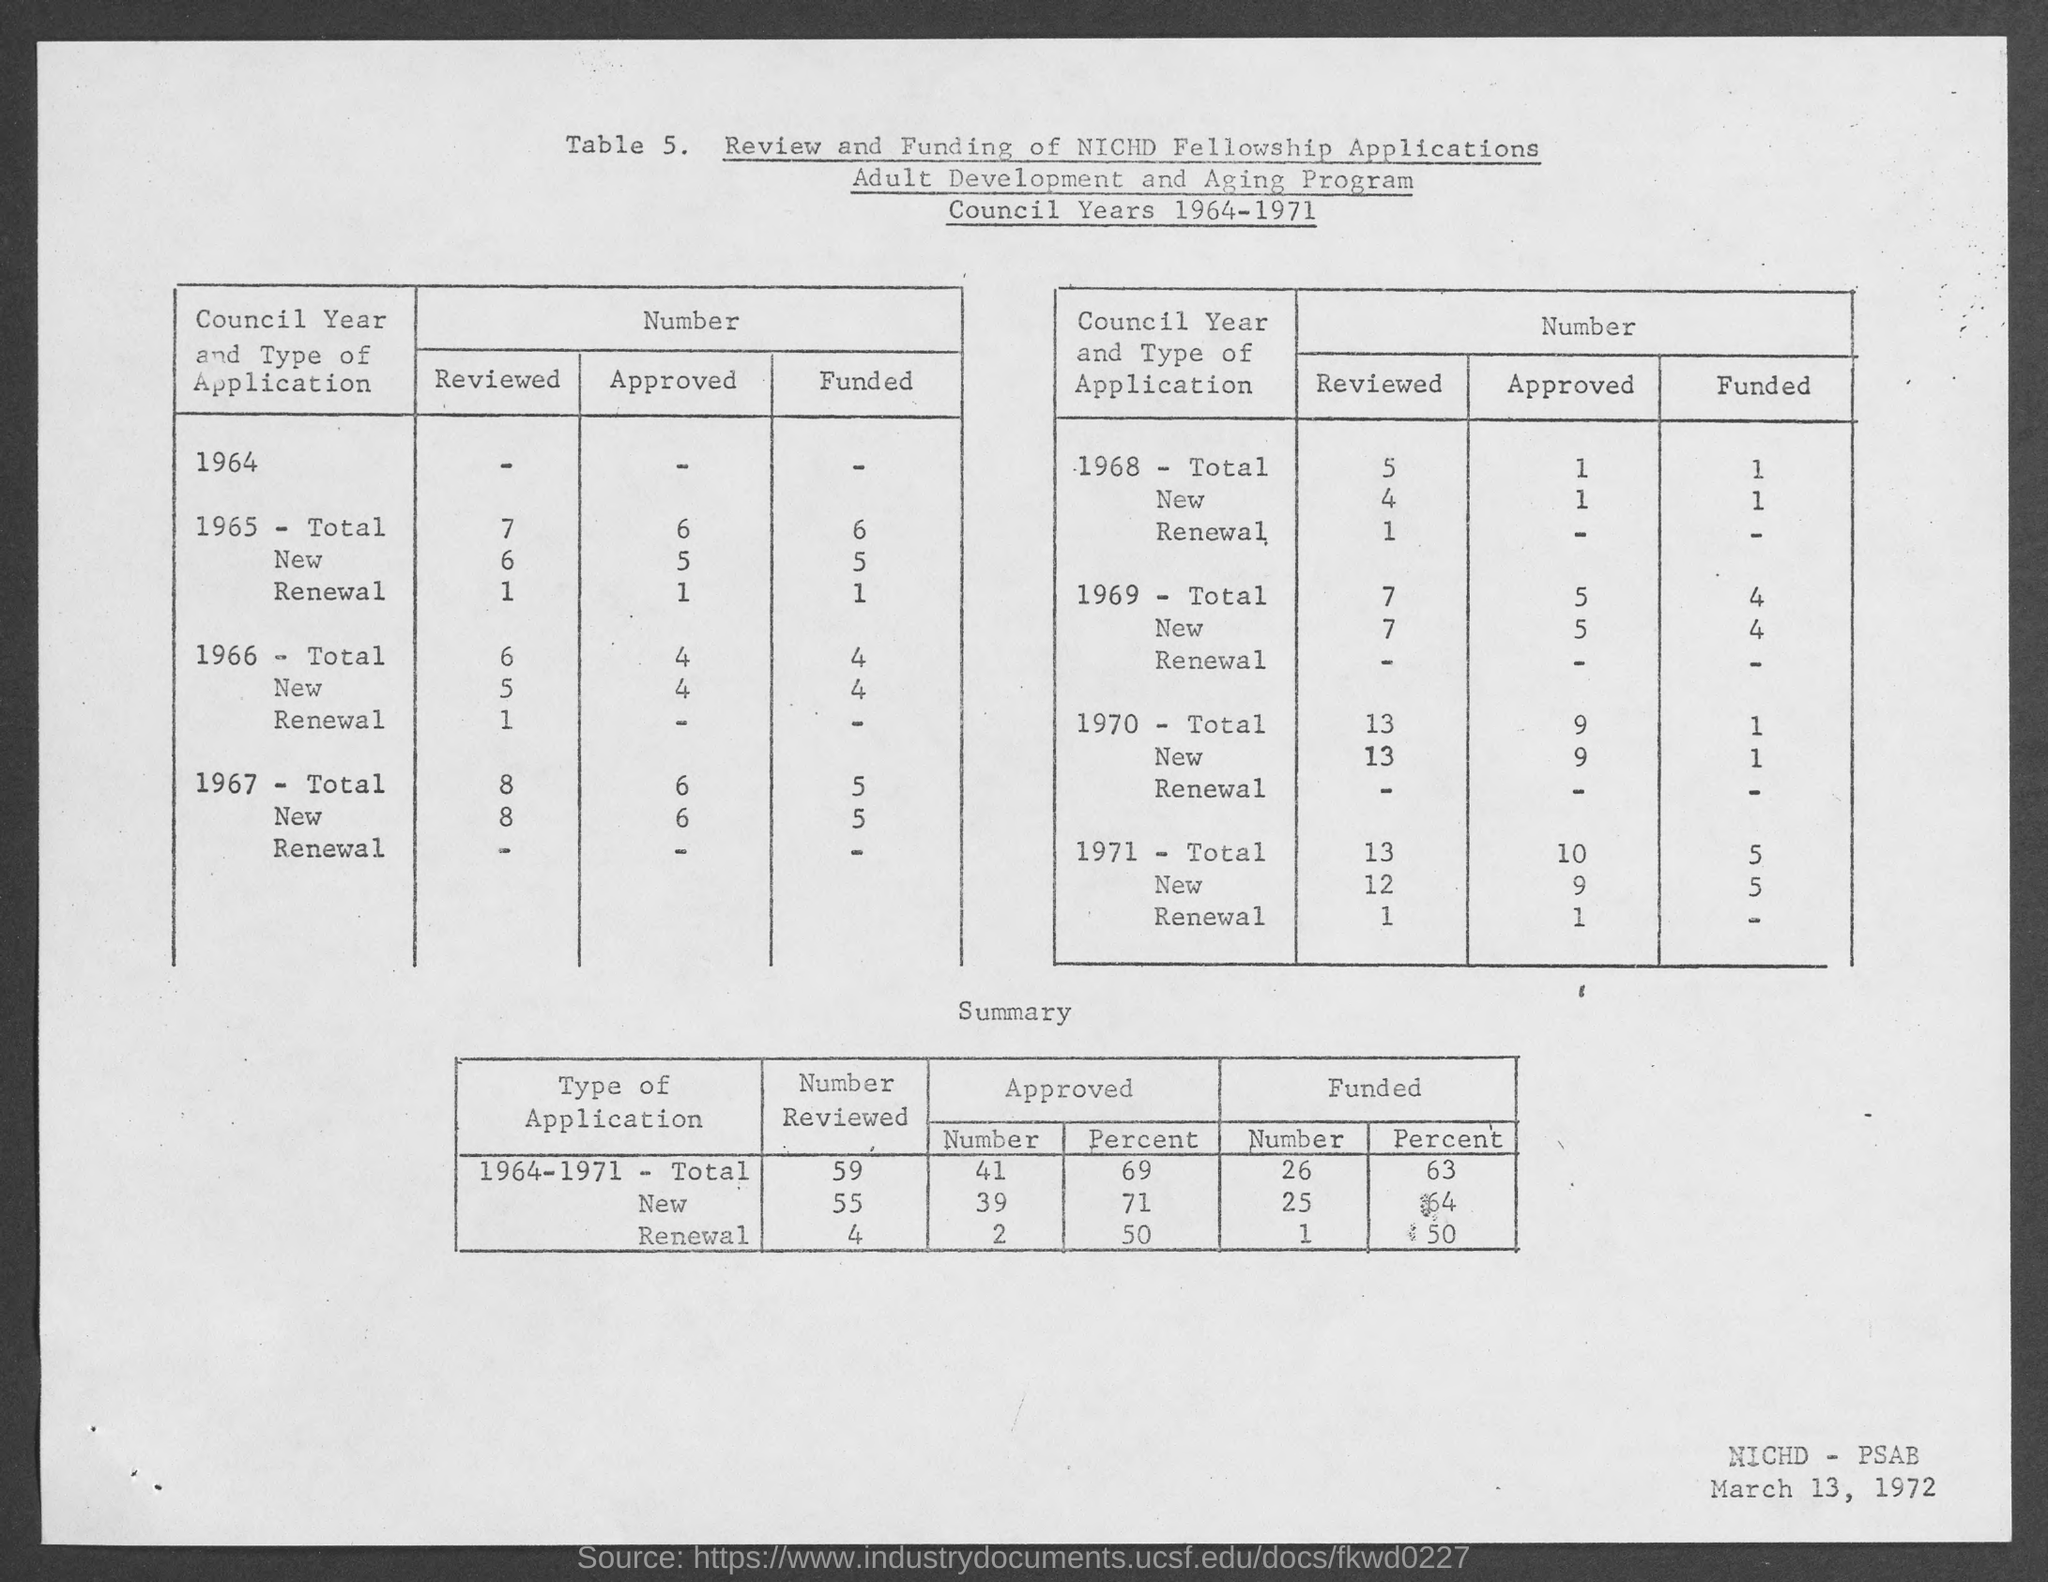What is the date at bottom- right corner of the page ?
Your answer should be compact. March 13, 1972. 